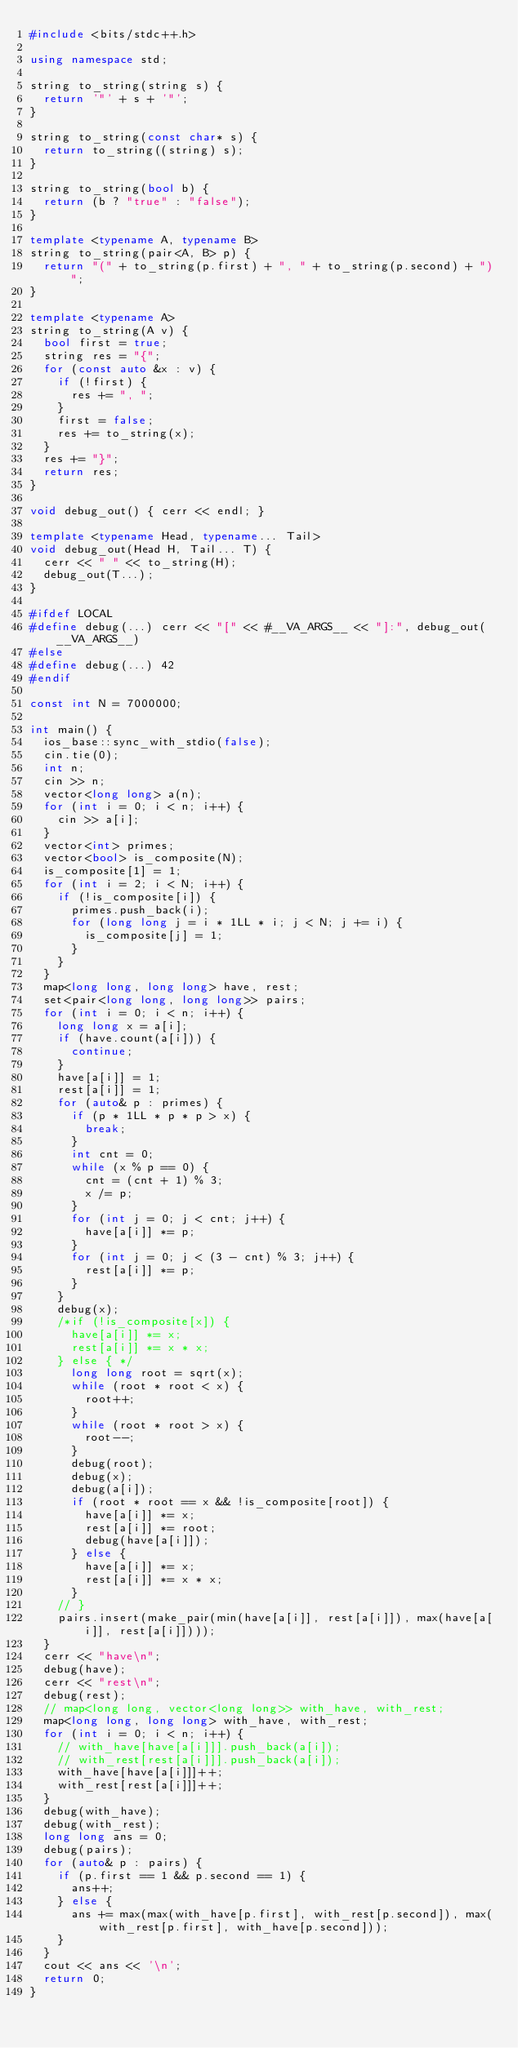Convert code to text. <code><loc_0><loc_0><loc_500><loc_500><_C++_>#include <bits/stdc++.h>

using namespace std;

string to_string(string s) {
  return '"' + s + '"';
}
 
string to_string(const char* s) {
  return to_string((string) s);
}
 
string to_string(bool b) {
  return (b ? "true" : "false");
}
 
template <typename A, typename B>
string to_string(pair<A, B> p) {
  return "(" + to_string(p.first) + ", " + to_string(p.second) + ")";
}
 
template <typename A>
string to_string(A v) {
  bool first = true;
  string res = "{";
  for (const auto &x : v) {
    if (!first) {
      res += ", ";
    }
    first = false;
    res += to_string(x);
  }
  res += "}";
  return res;
}
 
void debug_out() { cerr << endl; }
 
template <typename Head, typename... Tail>
void debug_out(Head H, Tail... T) {
  cerr << " " << to_string(H);
  debug_out(T...);
}
 
#ifdef LOCAL
#define debug(...) cerr << "[" << #__VA_ARGS__ << "]:", debug_out(__VA_ARGS__)
#else
#define debug(...) 42
#endif

const int N = 7000000;

int main() {
  ios_base::sync_with_stdio(false);
  cin.tie(0);
  int n;
  cin >> n;
  vector<long long> a(n);
  for (int i = 0; i < n; i++) {
    cin >> a[i];
  }
  vector<int> primes;
  vector<bool> is_composite(N);
  is_composite[1] = 1;
  for (int i = 2; i < N; i++) {
    if (!is_composite[i]) {
      primes.push_back(i);
      for (long long j = i * 1LL * i; j < N; j += i) {
        is_composite[j] = 1;
      }
    }
  }
  map<long long, long long> have, rest;
  set<pair<long long, long long>> pairs;
  for (int i = 0; i < n; i++) {
    long long x = a[i];
    if (have.count(a[i])) {
      continue;
    }
    have[a[i]] = 1;
    rest[a[i]] = 1;
    for (auto& p : primes) {
      if (p * 1LL * p * p > x) {
        break;
      }
      int cnt = 0;
      while (x % p == 0) {
        cnt = (cnt + 1) % 3;
        x /= p; 
      }
      for (int j = 0; j < cnt; j++) {
        have[a[i]] *= p;
      }
      for (int j = 0; j < (3 - cnt) % 3; j++) {
        rest[a[i]] *= p;
      } 
    }
    debug(x);
    /*if (!is_composite[x]) {
      have[a[i]] *= x;
      rest[a[i]] *= x * x;
    } else { */
      long long root = sqrt(x);
      while (root * root < x) {
        root++;
      }
      while (root * root > x) {
        root--;
      }
      debug(root);
      debug(x);
      debug(a[i]);
      if (root * root == x && !is_composite[root]) {
        have[a[i]] *= x;
        rest[a[i]] *= root;
        debug(have[a[i]]);
      } else {
        have[a[i]] *= x;
        rest[a[i]] *= x * x;
      }
    // }
    pairs.insert(make_pair(min(have[a[i]], rest[a[i]]), max(have[a[i]], rest[a[i]])));
  }
  cerr << "have\n";
  debug(have);
  cerr << "rest\n";
  debug(rest);
  // map<long long, vector<long long>> with_have, with_rest;
  map<long long, long long> with_have, with_rest;
  for (int i = 0; i < n; i++) {
    // with_have[have[a[i]]].push_back(a[i]);
    // with_rest[rest[a[i]]].push_back(a[i]);
    with_have[have[a[i]]]++;
    with_rest[rest[a[i]]]++;
  }
  debug(with_have);
  debug(with_rest);
  long long ans = 0;
  debug(pairs);
  for (auto& p : pairs) {
    if (p.first == 1 && p.second == 1) {
      ans++;
    } else {
      ans += max(max(with_have[p.first], with_rest[p.second]), max(with_rest[p.first], with_have[p.second]));
    }
  }
  cout << ans << '\n';
  return 0;
}</code> 